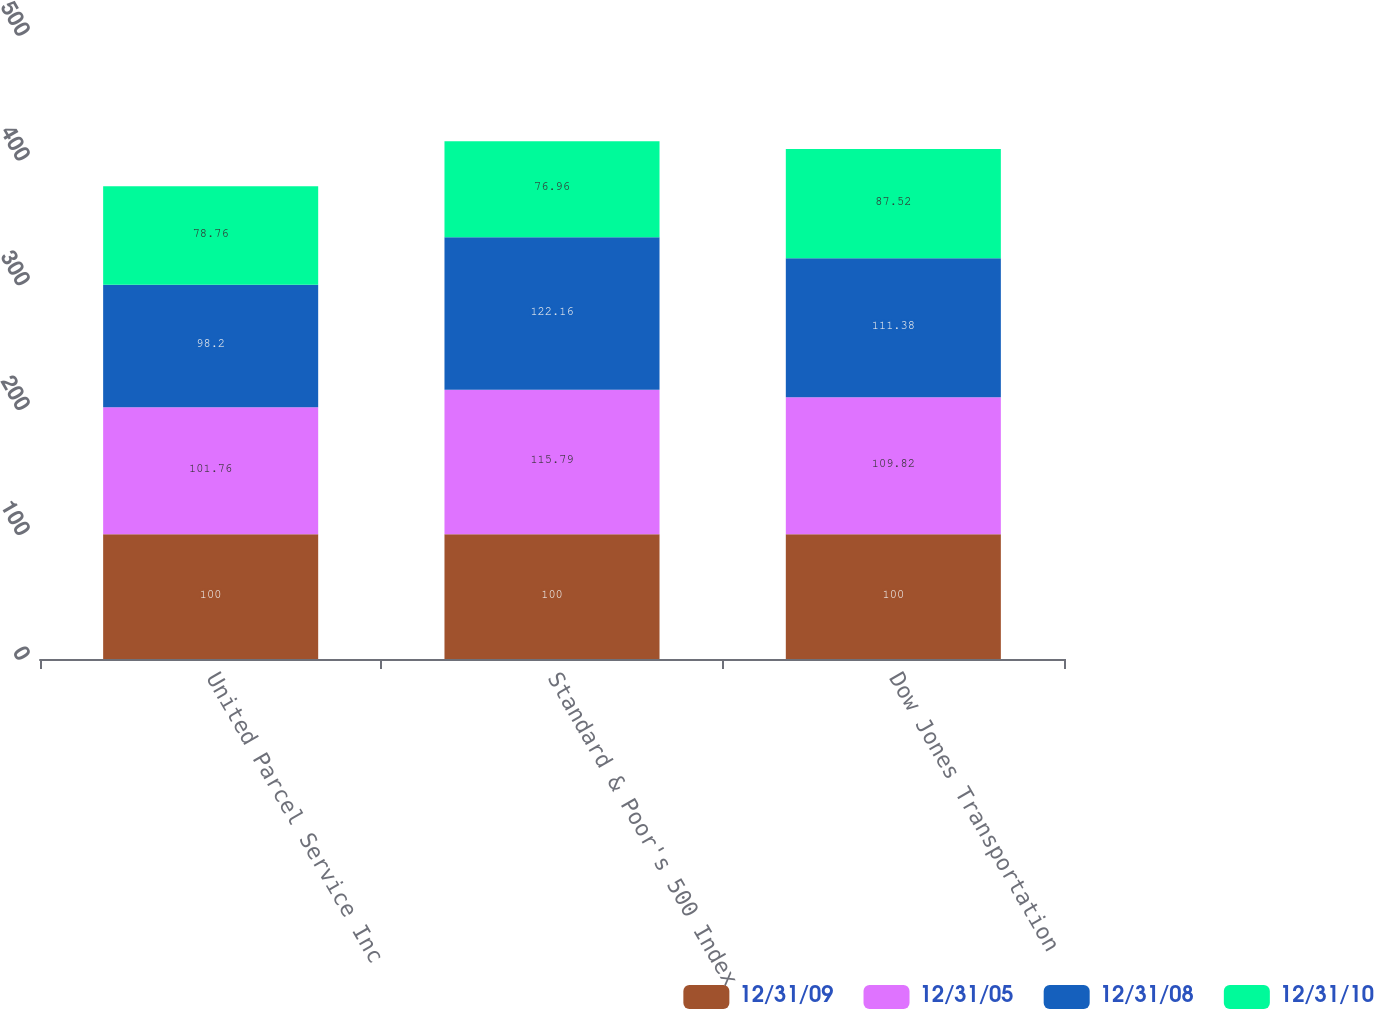Convert chart to OTSL. <chart><loc_0><loc_0><loc_500><loc_500><stacked_bar_chart><ecel><fcel>United Parcel Service Inc<fcel>Standard & Poor's 500 Index<fcel>Dow Jones Transportation<nl><fcel>12/31/09<fcel>100<fcel>100<fcel>100<nl><fcel>12/31/05<fcel>101.76<fcel>115.79<fcel>109.82<nl><fcel>12/31/08<fcel>98.2<fcel>122.16<fcel>111.38<nl><fcel>12/31/10<fcel>78.76<fcel>76.96<fcel>87.52<nl></chart> 